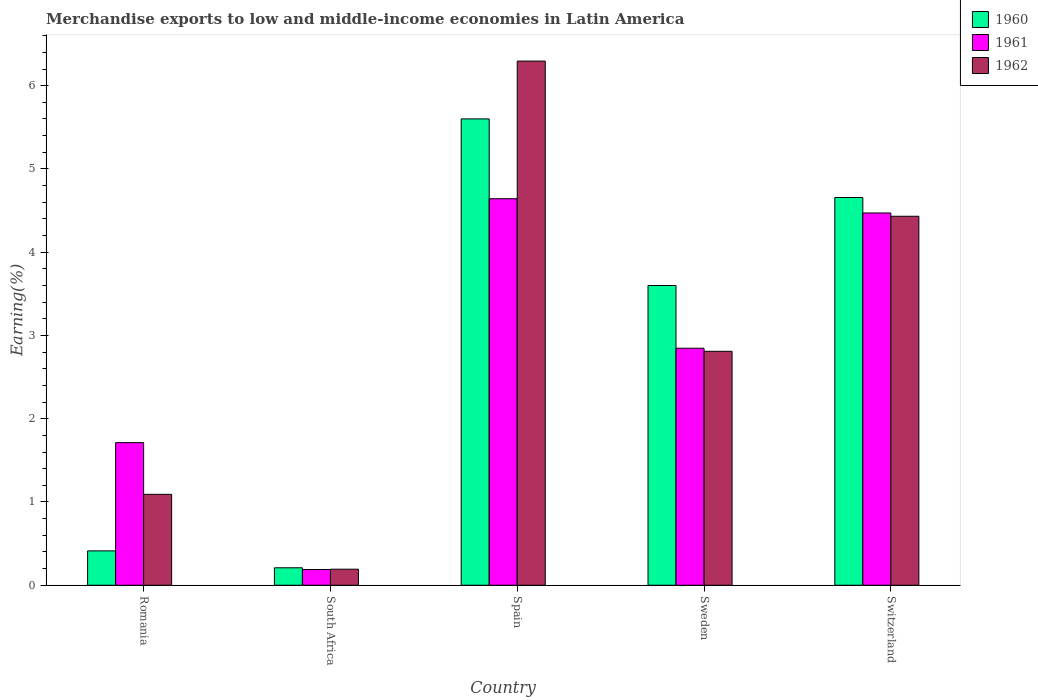How many different coloured bars are there?
Ensure brevity in your answer.  3. How many groups of bars are there?
Ensure brevity in your answer.  5. Are the number of bars per tick equal to the number of legend labels?
Keep it short and to the point. Yes. How many bars are there on the 3rd tick from the left?
Ensure brevity in your answer.  3. What is the label of the 3rd group of bars from the left?
Ensure brevity in your answer.  Spain. In how many cases, is the number of bars for a given country not equal to the number of legend labels?
Make the answer very short. 0. What is the percentage of amount earned from merchandise exports in 1960 in Romania?
Provide a short and direct response. 0.41. Across all countries, what is the maximum percentage of amount earned from merchandise exports in 1962?
Offer a very short reply. 6.3. Across all countries, what is the minimum percentage of amount earned from merchandise exports in 1960?
Make the answer very short. 0.21. In which country was the percentage of amount earned from merchandise exports in 1960 maximum?
Your response must be concise. Spain. In which country was the percentage of amount earned from merchandise exports in 1962 minimum?
Give a very brief answer. South Africa. What is the total percentage of amount earned from merchandise exports in 1961 in the graph?
Provide a short and direct response. 13.86. What is the difference between the percentage of amount earned from merchandise exports in 1961 in Spain and that in Switzerland?
Provide a short and direct response. 0.17. What is the difference between the percentage of amount earned from merchandise exports in 1961 in Spain and the percentage of amount earned from merchandise exports in 1960 in South Africa?
Offer a terse response. 4.43. What is the average percentage of amount earned from merchandise exports in 1961 per country?
Provide a short and direct response. 2.77. What is the difference between the percentage of amount earned from merchandise exports of/in 1960 and percentage of amount earned from merchandise exports of/in 1962 in Spain?
Keep it short and to the point. -0.69. In how many countries, is the percentage of amount earned from merchandise exports in 1962 greater than 5 %?
Your answer should be very brief. 1. What is the ratio of the percentage of amount earned from merchandise exports in 1962 in Romania to that in Spain?
Offer a terse response. 0.17. Is the percentage of amount earned from merchandise exports in 1961 in Spain less than that in Sweden?
Offer a very short reply. No. What is the difference between the highest and the second highest percentage of amount earned from merchandise exports in 1962?
Make the answer very short. -1.62. What is the difference between the highest and the lowest percentage of amount earned from merchandise exports in 1960?
Offer a terse response. 5.39. Is the sum of the percentage of amount earned from merchandise exports in 1960 in Romania and Spain greater than the maximum percentage of amount earned from merchandise exports in 1961 across all countries?
Make the answer very short. Yes. What does the 3rd bar from the left in Spain represents?
Your answer should be very brief. 1962. Is it the case that in every country, the sum of the percentage of amount earned from merchandise exports in 1961 and percentage of amount earned from merchandise exports in 1962 is greater than the percentage of amount earned from merchandise exports in 1960?
Make the answer very short. Yes. How many bars are there?
Ensure brevity in your answer.  15. Are all the bars in the graph horizontal?
Ensure brevity in your answer.  No. Are the values on the major ticks of Y-axis written in scientific E-notation?
Provide a short and direct response. No. What is the title of the graph?
Your answer should be compact. Merchandise exports to low and middle-income economies in Latin America. Does "1998" appear as one of the legend labels in the graph?
Your response must be concise. No. What is the label or title of the Y-axis?
Your response must be concise. Earning(%). What is the Earning(%) in 1960 in Romania?
Your answer should be compact. 0.41. What is the Earning(%) in 1961 in Romania?
Offer a very short reply. 1.71. What is the Earning(%) of 1962 in Romania?
Offer a terse response. 1.09. What is the Earning(%) of 1960 in South Africa?
Give a very brief answer. 0.21. What is the Earning(%) in 1961 in South Africa?
Your answer should be compact. 0.19. What is the Earning(%) in 1962 in South Africa?
Keep it short and to the point. 0.19. What is the Earning(%) in 1960 in Spain?
Ensure brevity in your answer.  5.6. What is the Earning(%) of 1961 in Spain?
Your answer should be very brief. 4.64. What is the Earning(%) in 1962 in Spain?
Give a very brief answer. 6.3. What is the Earning(%) of 1960 in Sweden?
Your answer should be very brief. 3.6. What is the Earning(%) of 1961 in Sweden?
Make the answer very short. 2.85. What is the Earning(%) of 1962 in Sweden?
Offer a very short reply. 2.81. What is the Earning(%) of 1960 in Switzerland?
Your answer should be very brief. 4.66. What is the Earning(%) in 1961 in Switzerland?
Keep it short and to the point. 4.47. What is the Earning(%) of 1962 in Switzerland?
Make the answer very short. 4.43. Across all countries, what is the maximum Earning(%) in 1960?
Give a very brief answer. 5.6. Across all countries, what is the maximum Earning(%) of 1961?
Your answer should be very brief. 4.64. Across all countries, what is the maximum Earning(%) in 1962?
Your answer should be compact. 6.3. Across all countries, what is the minimum Earning(%) in 1960?
Your answer should be compact. 0.21. Across all countries, what is the minimum Earning(%) of 1961?
Make the answer very short. 0.19. Across all countries, what is the minimum Earning(%) in 1962?
Your answer should be compact. 0.19. What is the total Earning(%) of 1960 in the graph?
Ensure brevity in your answer.  14.48. What is the total Earning(%) in 1961 in the graph?
Give a very brief answer. 13.86. What is the total Earning(%) in 1962 in the graph?
Provide a succinct answer. 14.82. What is the difference between the Earning(%) of 1960 in Romania and that in South Africa?
Offer a terse response. 0.2. What is the difference between the Earning(%) in 1961 in Romania and that in South Africa?
Your answer should be very brief. 1.52. What is the difference between the Earning(%) in 1962 in Romania and that in South Africa?
Ensure brevity in your answer.  0.9. What is the difference between the Earning(%) in 1960 in Romania and that in Spain?
Give a very brief answer. -5.19. What is the difference between the Earning(%) in 1961 in Romania and that in Spain?
Ensure brevity in your answer.  -2.93. What is the difference between the Earning(%) in 1962 in Romania and that in Spain?
Keep it short and to the point. -5.2. What is the difference between the Earning(%) in 1960 in Romania and that in Sweden?
Ensure brevity in your answer.  -3.19. What is the difference between the Earning(%) in 1961 in Romania and that in Sweden?
Provide a succinct answer. -1.13. What is the difference between the Earning(%) of 1962 in Romania and that in Sweden?
Provide a short and direct response. -1.72. What is the difference between the Earning(%) of 1960 in Romania and that in Switzerland?
Give a very brief answer. -4.24. What is the difference between the Earning(%) of 1961 in Romania and that in Switzerland?
Give a very brief answer. -2.76. What is the difference between the Earning(%) of 1962 in Romania and that in Switzerland?
Your answer should be very brief. -3.34. What is the difference between the Earning(%) of 1960 in South Africa and that in Spain?
Your answer should be very brief. -5.39. What is the difference between the Earning(%) of 1961 in South Africa and that in Spain?
Provide a short and direct response. -4.45. What is the difference between the Earning(%) in 1962 in South Africa and that in Spain?
Make the answer very short. -6.1. What is the difference between the Earning(%) in 1960 in South Africa and that in Sweden?
Offer a very short reply. -3.39. What is the difference between the Earning(%) of 1961 in South Africa and that in Sweden?
Provide a succinct answer. -2.66. What is the difference between the Earning(%) in 1962 in South Africa and that in Sweden?
Provide a succinct answer. -2.62. What is the difference between the Earning(%) in 1960 in South Africa and that in Switzerland?
Your answer should be very brief. -4.45. What is the difference between the Earning(%) in 1961 in South Africa and that in Switzerland?
Make the answer very short. -4.28. What is the difference between the Earning(%) of 1962 in South Africa and that in Switzerland?
Your answer should be compact. -4.24. What is the difference between the Earning(%) of 1960 in Spain and that in Sweden?
Give a very brief answer. 2. What is the difference between the Earning(%) in 1961 in Spain and that in Sweden?
Make the answer very short. 1.8. What is the difference between the Earning(%) of 1962 in Spain and that in Sweden?
Make the answer very short. 3.49. What is the difference between the Earning(%) of 1960 in Spain and that in Switzerland?
Provide a succinct answer. 0.94. What is the difference between the Earning(%) in 1961 in Spain and that in Switzerland?
Provide a succinct answer. 0.17. What is the difference between the Earning(%) in 1962 in Spain and that in Switzerland?
Offer a very short reply. 1.86. What is the difference between the Earning(%) of 1960 in Sweden and that in Switzerland?
Provide a succinct answer. -1.06. What is the difference between the Earning(%) in 1961 in Sweden and that in Switzerland?
Give a very brief answer. -1.62. What is the difference between the Earning(%) of 1962 in Sweden and that in Switzerland?
Offer a terse response. -1.62. What is the difference between the Earning(%) of 1960 in Romania and the Earning(%) of 1961 in South Africa?
Make the answer very short. 0.22. What is the difference between the Earning(%) of 1960 in Romania and the Earning(%) of 1962 in South Africa?
Provide a short and direct response. 0.22. What is the difference between the Earning(%) of 1961 in Romania and the Earning(%) of 1962 in South Africa?
Your answer should be compact. 1.52. What is the difference between the Earning(%) of 1960 in Romania and the Earning(%) of 1961 in Spain?
Your answer should be very brief. -4.23. What is the difference between the Earning(%) in 1960 in Romania and the Earning(%) in 1962 in Spain?
Give a very brief answer. -5.88. What is the difference between the Earning(%) of 1961 in Romania and the Earning(%) of 1962 in Spain?
Your answer should be compact. -4.58. What is the difference between the Earning(%) in 1960 in Romania and the Earning(%) in 1961 in Sweden?
Provide a short and direct response. -2.43. What is the difference between the Earning(%) of 1960 in Romania and the Earning(%) of 1962 in Sweden?
Make the answer very short. -2.4. What is the difference between the Earning(%) of 1961 in Romania and the Earning(%) of 1962 in Sweden?
Your answer should be compact. -1.1. What is the difference between the Earning(%) of 1960 in Romania and the Earning(%) of 1961 in Switzerland?
Give a very brief answer. -4.06. What is the difference between the Earning(%) of 1960 in Romania and the Earning(%) of 1962 in Switzerland?
Offer a very short reply. -4.02. What is the difference between the Earning(%) of 1961 in Romania and the Earning(%) of 1962 in Switzerland?
Offer a very short reply. -2.72. What is the difference between the Earning(%) of 1960 in South Africa and the Earning(%) of 1961 in Spain?
Your response must be concise. -4.43. What is the difference between the Earning(%) of 1960 in South Africa and the Earning(%) of 1962 in Spain?
Your response must be concise. -6.09. What is the difference between the Earning(%) in 1961 in South Africa and the Earning(%) in 1962 in Spain?
Ensure brevity in your answer.  -6.11. What is the difference between the Earning(%) of 1960 in South Africa and the Earning(%) of 1961 in Sweden?
Your answer should be compact. -2.64. What is the difference between the Earning(%) in 1960 in South Africa and the Earning(%) in 1962 in Sweden?
Your answer should be compact. -2.6. What is the difference between the Earning(%) of 1961 in South Africa and the Earning(%) of 1962 in Sweden?
Ensure brevity in your answer.  -2.62. What is the difference between the Earning(%) of 1960 in South Africa and the Earning(%) of 1961 in Switzerland?
Give a very brief answer. -4.26. What is the difference between the Earning(%) in 1960 in South Africa and the Earning(%) in 1962 in Switzerland?
Offer a terse response. -4.22. What is the difference between the Earning(%) in 1961 in South Africa and the Earning(%) in 1962 in Switzerland?
Provide a short and direct response. -4.24. What is the difference between the Earning(%) in 1960 in Spain and the Earning(%) in 1961 in Sweden?
Provide a short and direct response. 2.75. What is the difference between the Earning(%) in 1960 in Spain and the Earning(%) in 1962 in Sweden?
Make the answer very short. 2.79. What is the difference between the Earning(%) of 1961 in Spain and the Earning(%) of 1962 in Sweden?
Your answer should be compact. 1.83. What is the difference between the Earning(%) of 1960 in Spain and the Earning(%) of 1961 in Switzerland?
Offer a terse response. 1.13. What is the difference between the Earning(%) of 1960 in Spain and the Earning(%) of 1962 in Switzerland?
Your response must be concise. 1.17. What is the difference between the Earning(%) in 1961 in Spain and the Earning(%) in 1962 in Switzerland?
Your answer should be very brief. 0.21. What is the difference between the Earning(%) of 1960 in Sweden and the Earning(%) of 1961 in Switzerland?
Keep it short and to the point. -0.87. What is the difference between the Earning(%) in 1960 in Sweden and the Earning(%) in 1962 in Switzerland?
Make the answer very short. -0.83. What is the difference between the Earning(%) of 1961 in Sweden and the Earning(%) of 1962 in Switzerland?
Your answer should be very brief. -1.58. What is the average Earning(%) in 1960 per country?
Make the answer very short. 2.9. What is the average Earning(%) in 1961 per country?
Make the answer very short. 2.77. What is the average Earning(%) of 1962 per country?
Ensure brevity in your answer.  2.96. What is the difference between the Earning(%) in 1960 and Earning(%) in 1961 in Romania?
Keep it short and to the point. -1.3. What is the difference between the Earning(%) of 1960 and Earning(%) of 1962 in Romania?
Your response must be concise. -0.68. What is the difference between the Earning(%) of 1961 and Earning(%) of 1962 in Romania?
Your answer should be compact. 0.62. What is the difference between the Earning(%) of 1960 and Earning(%) of 1961 in South Africa?
Provide a succinct answer. 0.02. What is the difference between the Earning(%) of 1960 and Earning(%) of 1962 in South Africa?
Keep it short and to the point. 0.02. What is the difference between the Earning(%) of 1961 and Earning(%) of 1962 in South Africa?
Offer a very short reply. -0. What is the difference between the Earning(%) of 1960 and Earning(%) of 1961 in Spain?
Provide a short and direct response. 0.96. What is the difference between the Earning(%) in 1960 and Earning(%) in 1962 in Spain?
Your answer should be compact. -0.69. What is the difference between the Earning(%) in 1961 and Earning(%) in 1962 in Spain?
Your response must be concise. -1.65. What is the difference between the Earning(%) of 1960 and Earning(%) of 1961 in Sweden?
Provide a succinct answer. 0.75. What is the difference between the Earning(%) of 1960 and Earning(%) of 1962 in Sweden?
Your answer should be very brief. 0.79. What is the difference between the Earning(%) in 1961 and Earning(%) in 1962 in Sweden?
Your answer should be very brief. 0.04. What is the difference between the Earning(%) in 1960 and Earning(%) in 1961 in Switzerland?
Give a very brief answer. 0.19. What is the difference between the Earning(%) of 1960 and Earning(%) of 1962 in Switzerland?
Offer a very short reply. 0.23. What is the difference between the Earning(%) of 1961 and Earning(%) of 1962 in Switzerland?
Offer a very short reply. 0.04. What is the ratio of the Earning(%) of 1960 in Romania to that in South Africa?
Offer a terse response. 1.97. What is the ratio of the Earning(%) of 1961 in Romania to that in South Africa?
Your answer should be compact. 9.07. What is the ratio of the Earning(%) of 1962 in Romania to that in South Africa?
Your answer should be very brief. 5.67. What is the ratio of the Earning(%) of 1960 in Romania to that in Spain?
Offer a terse response. 0.07. What is the ratio of the Earning(%) of 1961 in Romania to that in Spain?
Provide a succinct answer. 0.37. What is the ratio of the Earning(%) of 1962 in Romania to that in Spain?
Make the answer very short. 0.17. What is the ratio of the Earning(%) in 1960 in Romania to that in Sweden?
Offer a very short reply. 0.11. What is the ratio of the Earning(%) in 1961 in Romania to that in Sweden?
Make the answer very short. 0.6. What is the ratio of the Earning(%) in 1962 in Romania to that in Sweden?
Ensure brevity in your answer.  0.39. What is the ratio of the Earning(%) in 1960 in Romania to that in Switzerland?
Ensure brevity in your answer.  0.09. What is the ratio of the Earning(%) in 1961 in Romania to that in Switzerland?
Provide a short and direct response. 0.38. What is the ratio of the Earning(%) of 1962 in Romania to that in Switzerland?
Provide a short and direct response. 0.25. What is the ratio of the Earning(%) in 1960 in South Africa to that in Spain?
Provide a short and direct response. 0.04. What is the ratio of the Earning(%) of 1961 in South Africa to that in Spain?
Offer a terse response. 0.04. What is the ratio of the Earning(%) in 1962 in South Africa to that in Spain?
Make the answer very short. 0.03. What is the ratio of the Earning(%) in 1960 in South Africa to that in Sweden?
Keep it short and to the point. 0.06. What is the ratio of the Earning(%) of 1961 in South Africa to that in Sweden?
Give a very brief answer. 0.07. What is the ratio of the Earning(%) of 1962 in South Africa to that in Sweden?
Your answer should be very brief. 0.07. What is the ratio of the Earning(%) in 1960 in South Africa to that in Switzerland?
Make the answer very short. 0.04. What is the ratio of the Earning(%) in 1961 in South Africa to that in Switzerland?
Keep it short and to the point. 0.04. What is the ratio of the Earning(%) in 1962 in South Africa to that in Switzerland?
Give a very brief answer. 0.04. What is the ratio of the Earning(%) in 1960 in Spain to that in Sweden?
Give a very brief answer. 1.56. What is the ratio of the Earning(%) in 1961 in Spain to that in Sweden?
Make the answer very short. 1.63. What is the ratio of the Earning(%) of 1962 in Spain to that in Sweden?
Provide a short and direct response. 2.24. What is the ratio of the Earning(%) of 1960 in Spain to that in Switzerland?
Your response must be concise. 1.2. What is the ratio of the Earning(%) of 1961 in Spain to that in Switzerland?
Your answer should be compact. 1.04. What is the ratio of the Earning(%) of 1962 in Spain to that in Switzerland?
Give a very brief answer. 1.42. What is the ratio of the Earning(%) of 1960 in Sweden to that in Switzerland?
Offer a very short reply. 0.77. What is the ratio of the Earning(%) in 1961 in Sweden to that in Switzerland?
Offer a terse response. 0.64. What is the ratio of the Earning(%) in 1962 in Sweden to that in Switzerland?
Provide a succinct answer. 0.63. What is the difference between the highest and the second highest Earning(%) in 1960?
Provide a short and direct response. 0.94. What is the difference between the highest and the second highest Earning(%) in 1961?
Your answer should be compact. 0.17. What is the difference between the highest and the second highest Earning(%) in 1962?
Your answer should be compact. 1.86. What is the difference between the highest and the lowest Earning(%) of 1960?
Your answer should be compact. 5.39. What is the difference between the highest and the lowest Earning(%) of 1961?
Ensure brevity in your answer.  4.45. What is the difference between the highest and the lowest Earning(%) of 1962?
Provide a short and direct response. 6.1. 